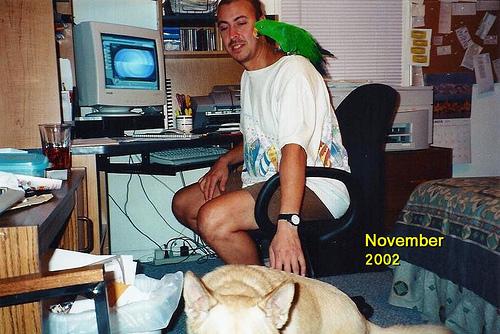What color is the bird?
Write a very short answer. Green. What color is the bedspread?
Be succinct. Blue. What is the man touching?
Keep it brief. Dog. 